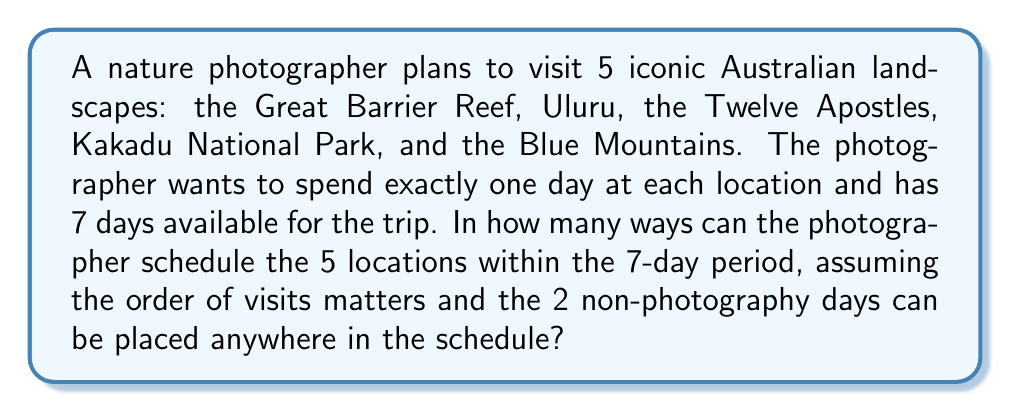Can you solve this math problem? Let's approach this step-by-step:

1) First, we need to consider the total number of ways to arrange the 5 locations. This is a straightforward permutation:
   $$P(5,5) = 5! = 5 \times 4 \times 3 \times 2 \times 1 = 120$$

2) Now, we need to consider the placement of the 2 non-photography days. We can think of this as inserting 2 additional objects (the non-photography days) into 6 possible spaces: before the first location, after the last location, and between any two locations.

3) This is equivalent to choosing 2 positions out of 6 possible positions for the non-photography days, which is a combination problem:
   $$C(6,2) = \frac{6!}{2!(6-2)!} = \frac{6 \times 5}{2 \times 1} = 15$$

4) By the multiplication principle, the total number of unique schedules is the product of the number of ways to arrange the locations and the number of ways to insert the non-photography days:
   $$120 \times 15 = 1800$$

Therefore, there are 1800 unique ways to schedule the trip.
Answer: 1800 